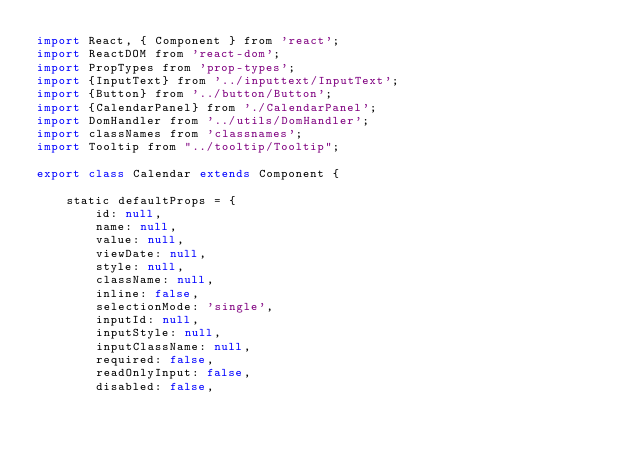Convert code to text. <code><loc_0><loc_0><loc_500><loc_500><_JavaScript_>import React, { Component } from 'react';
import ReactDOM from 'react-dom';
import PropTypes from 'prop-types';
import {InputText} from '../inputtext/InputText';
import {Button} from '../button/Button';
import {CalendarPanel} from './CalendarPanel';
import DomHandler from '../utils/DomHandler';
import classNames from 'classnames';
import Tooltip from "../tooltip/Tooltip";

export class Calendar extends Component {

    static defaultProps = {
        id: null,
        name: null,
        value: null,
        viewDate: null,
        style: null,
        className: null,
        inline: false,
        selectionMode: 'single',
        inputId: null,
        inputStyle: null,
        inputClassName: null,
        required: false,
        readOnlyInput: false,
        disabled: false,</code> 